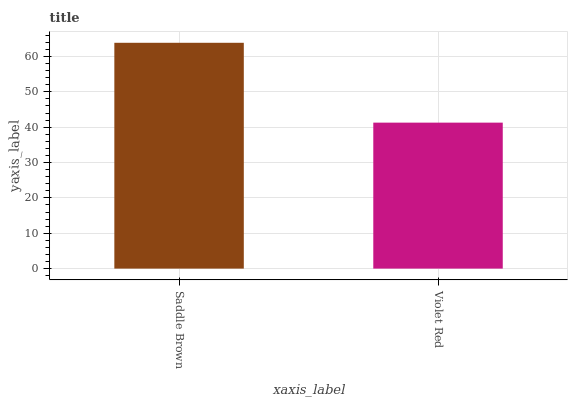Is Violet Red the minimum?
Answer yes or no. Yes. Is Saddle Brown the maximum?
Answer yes or no. Yes. Is Violet Red the maximum?
Answer yes or no. No. Is Saddle Brown greater than Violet Red?
Answer yes or no. Yes. Is Violet Red less than Saddle Brown?
Answer yes or no. Yes. Is Violet Red greater than Saddle Brown?
Answer yes or no. No. Is Saddle Brown less than Violet Red?
Answer yes or no. No. Is Saddle Brown the high median?
Answer yes or no. Yes. Is Violet Red the low median?
Answer yes or no. Yes. Is Violet Red the high median?
Answer yes or no. No. Is Saddle Brown the low median?
Answer yes or no. No. 